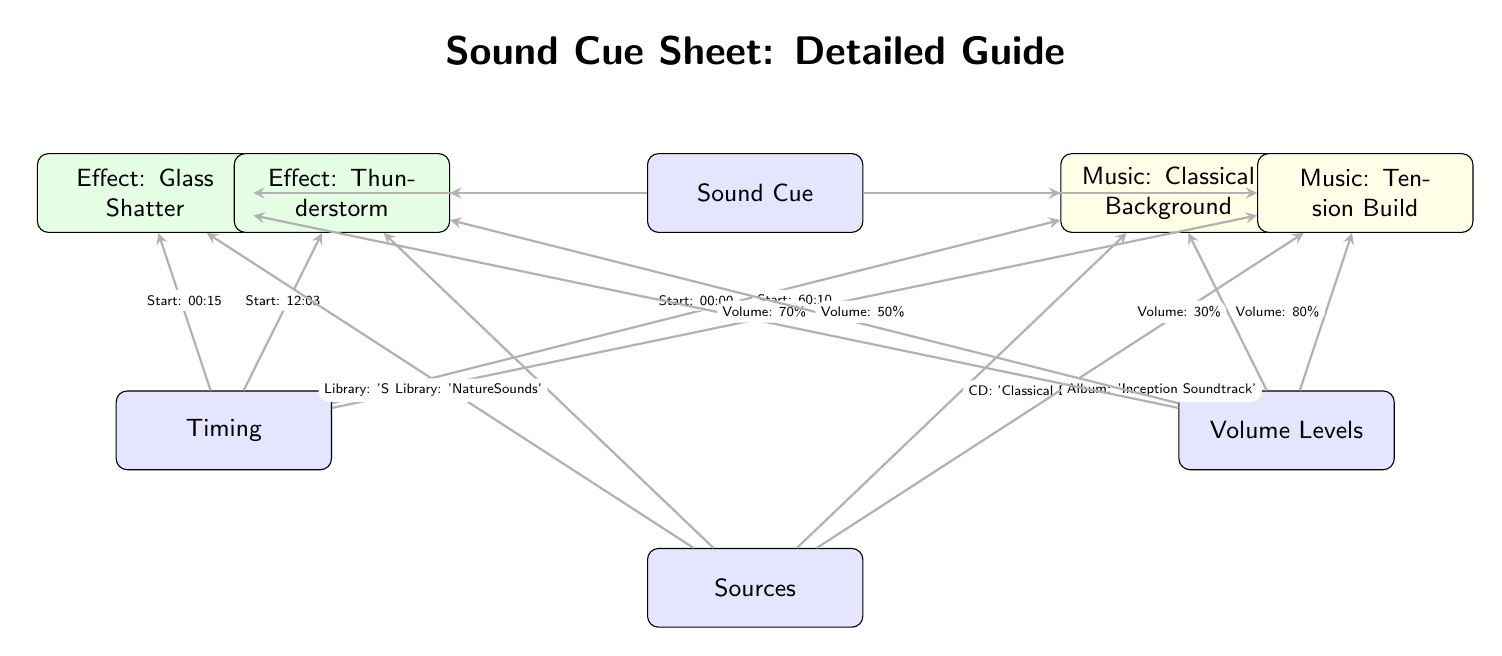What is the timing for the glass shatter effect? The glass shatter effect is connected to the timing node, which shows its start time is marked as 00:15. This information can be found directly next to the connection line leading from the timing node to the glass node.
Answer: Start: 00:15 What volume level is assigned to the classical background music? The classical background music is linked from the volume node, which indicates its volume level as 30%. This can be confirmed by following the edge from volume to the classical node, where the volume label is located.
Answer: Volume: 30% How many music cues are listed in the diagram? There are two nodes that indicate music cues on the right side (classical background and tension build). By counting these specific nodes, we can arrive at the number of music cues.
Answer: 2 Which sound effect has the highest volume level? By comparing the volume levels indicated next to each sound effect, the highest is identified as the tension build, with a volume of 80%. This requires looking at the volume levels for each sound effect to determine which is the greatest.
Answer: Volume: 80% What library is the thunderstorm effect sourced from? The thunderstorm effect is directly connected to the sources node. The label next to this connection indicates that the source is 'NatureSounds', clearly showing where the sound effect originates.
Answer: Library: 'NatureSounds' What is the timing for the tension build music cue? The tension build is linked to the timing node, displaying its start time as 60:10, found next to the edge leading from timing to the tension node. This information is necessary for understanding cue timing.
Answer: Start: 60:10 How many sound effects are depicted in the diagram? There are two sound effects (glass shatter and thunderstorm) shown on the left side of the diagram, requiring a count of the nodes connected to the sound cue node to determine the total number of sound effects.
Answer: 2 What type of cue is the thunderstorm classified as? The thunderstorm is categorized as an effect in the diagram, which is labeled near the thunder node. This type classification can be gleaned from the color coding and type indications in the diagram structure.
Answer: Effect: Thunderstorm Which album is the tension build music cue from? The tension build cue is connected to the sources node, labeled as being from the 'Inception Soundtrack', which is clearly indicated next to the volume level on the tension node. This shows its source directly.
Answer: Album: 'Inception Soundtrack' 